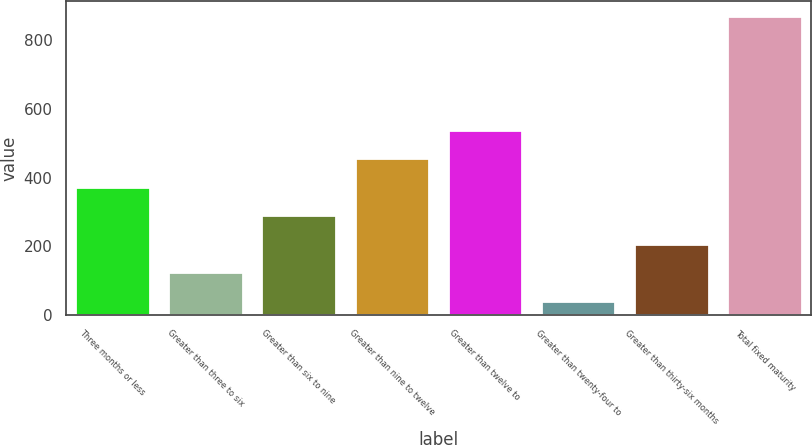Convert chart. <chart><loc_0><loc_0><loc_500><loc_500><bar_chart><fcel>Three months or less<fcel>Greater than three to six<fcel>Greater than six to nine<fcel>Greater than nine to twelve<fcel>Greater than twelve to<fcel>Greater than twenty-four to<fcel>Greater than thirty-six months<fcel>Total fixed maturity<nl><fcel>373.08<fcel>124.17<fcel>290.11<fcel>456.05<fcel>539.02<fcel>41.2<fcel>207.14<fcel>870.9<nl></chart> 